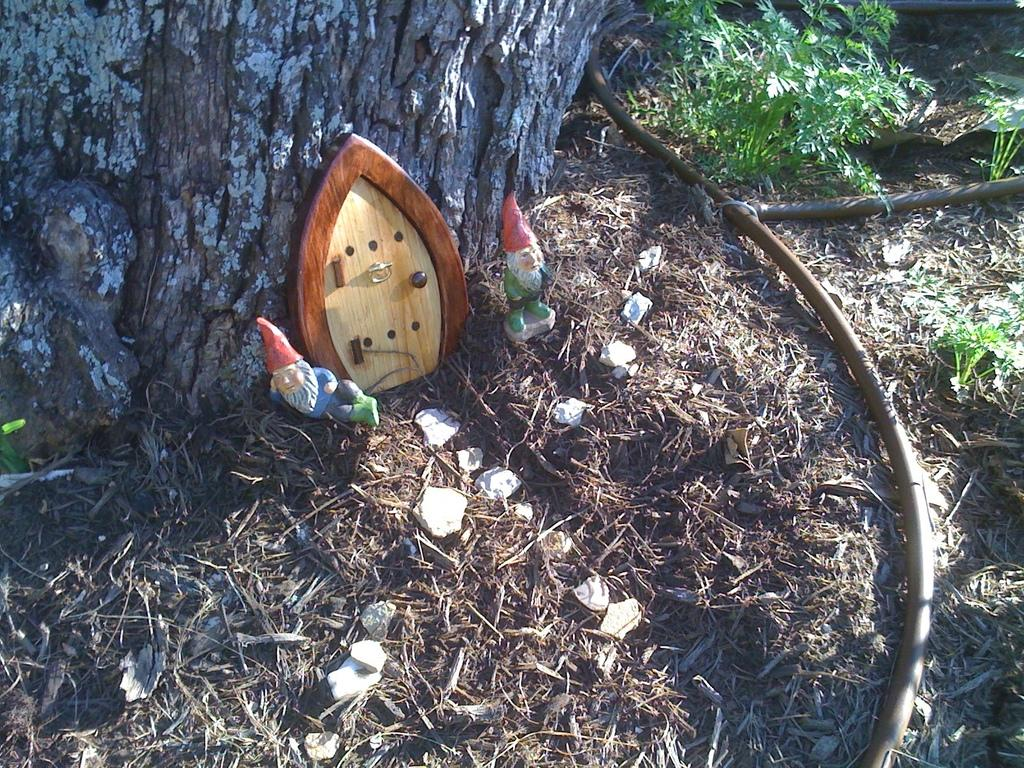What type of vegetation can be seen in the image? There are plants and grass in the image. What other objects can be found in the image? There are stones, two toys, and a door on a tree trunk in the image. What type of bomb is hidden among the plants in the image? There is no bomb present in the image; it only contains plants, grass, stones, toys, and a door on a tree trunk. 